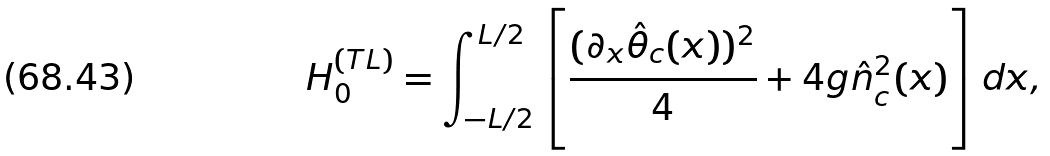Convert formula to latex. <formula><loc_0><loc_0><loc_500><loc_500>H _ { 0 } ^ { ( T L ) } = \int _ { - L / 2 } ^ { L / 2 } \left [ \frac { ( \partial _ { x } \hat { \theta } _ { c } ( x ) ) ^ { 2 } } { 4 } + 4 g \hat { n } _ { c } ^ { 2 } ( x ) \right ] d x ,</formula> 